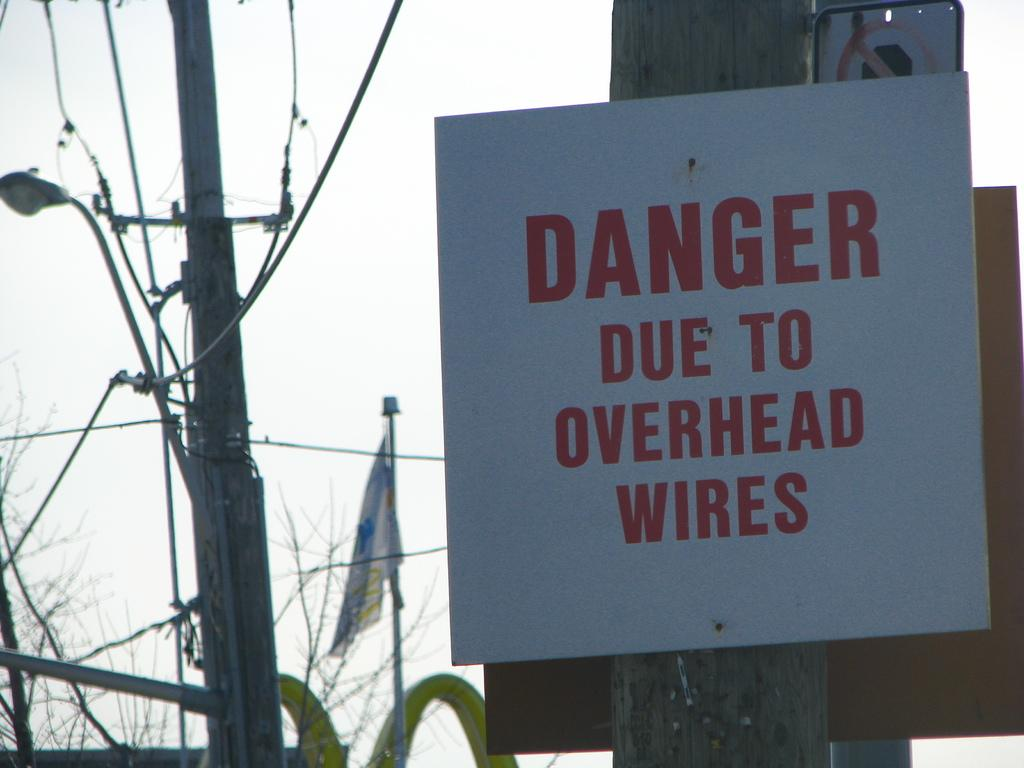What structure can be seen in the image? There is an electrical pole in the image. What is attached to the electrical pole? There is a flag in the image, attached to the electrical pole. What type of vegetation is present in the image? There are trees in the image. What can be found on a flat surface in the image? There is a board with text in the image. How many pizzas are being served at the quinceañera in the image? There is no quinceañera or pizzas present in the image. What type of holiday is being celebrated in the image? There is no holiday being celebrated in the image. 